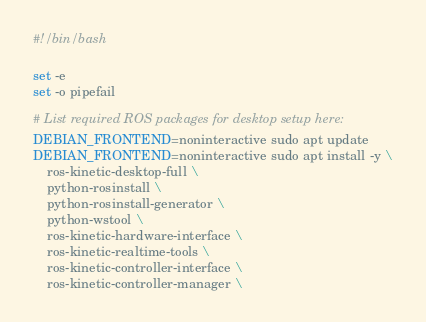Convert code to text. <code><loc_0><loc_0><loc_500><loc_500><_Bash_>#!/bin/bash

set -e
set -o pipefail

# List required ROS packages for desktop setup here:
DEBIAN_FRONTEND=noninteractive sudo apt update
DEBIAN_FRONTEND=noninteractive sudo apt install -y \
	ros-kinetic-desktop-full \
	python-rosinstall \
	python-rosinstall-generator \
	python-wstool \
	ros-kinetic-hardware-interface \
	ros-kinetic-realtime-tools \
	ros-kinetic-controller-interface \
	ros-kinetic-controller-manager \</code> 